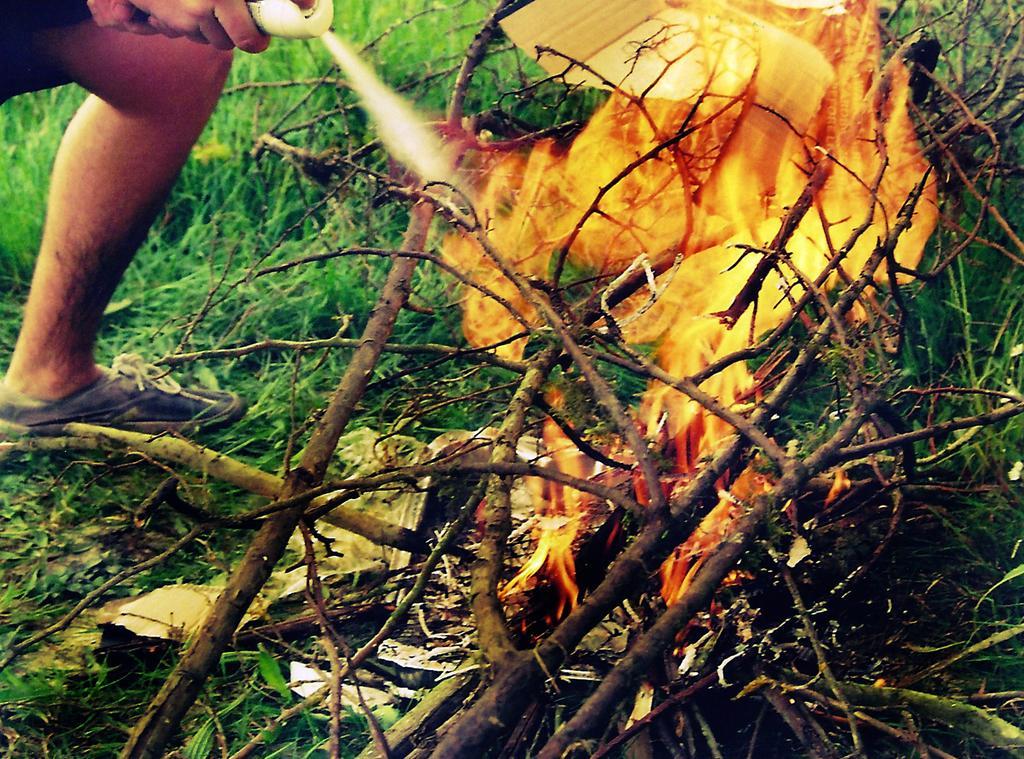Can you describe this image briefly? In the center of the image we can see fire and some sticks. In the background of the image we can see a grass. At the top left corner we can see a person is holding bottle. 